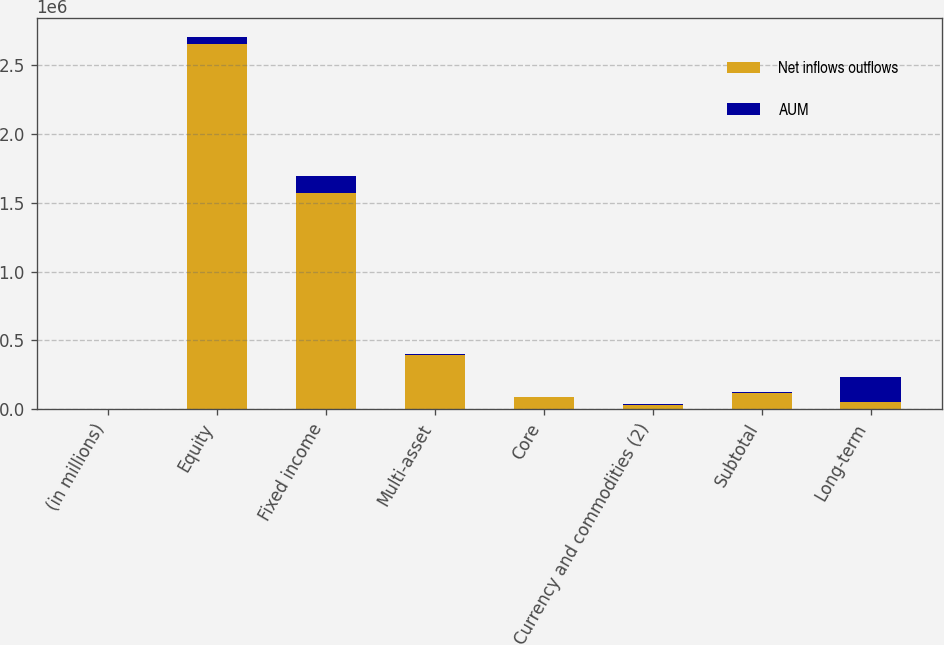<chart> <loc_0><loc_0><loc_500><loc_500><stacked_bar_chart><ecel><fcel>(in millions)<fcel>Equity<fcel>Fixed income<fcel>Multi-asset<fcel>Core<fcel>Currency and commodities (2)<fcel>Subtotal<fcel>Long-term<nl><fcel>Net inflows outflows<fcel>2016<fcel>2.65718e+06<fcel>1.57236e+06<fcel>395007<fcel>88630<fcel>28308<fcel>116938<fcel>51424<nl><fcel>AUM<fcel>2016<fcel>51424<fcel>119955<fcel>4227<fcel>1165<fcel>6123<fcel>4958<fcel>180564<nl></chart> 